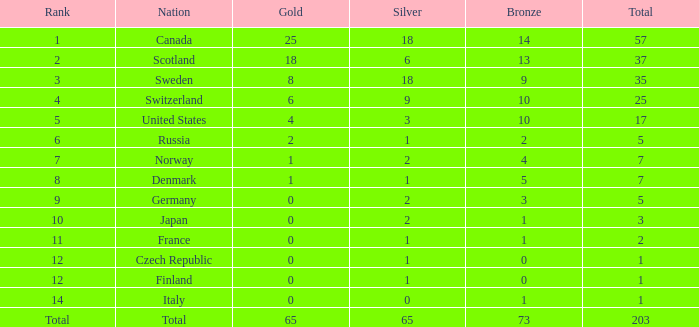What is the lowest total when the rank is 14 and the gold medals is larger than 0? None. Write the full table. {'header': ['Rank', 'Nation', 'Gold', 'Silver', 'Bronze', 'Total'], 'rows': [['1', 'Canada', '25', '18', '14', '57'], ['2', 'Scotland', '18', '6', '13', '37'], ['3', 'Sweden', '8', '18', '9', '35'], ['4', 'Switzerland', '6', '9', '10', '25'], ['5', 'United States', '4', '3', '10', '17'], ['6', 'Russia', '2', '1', '2', '5'], ['7', 'Norway', '1', '2', '4', '7'], ['8', 'Denmark', '1', '1', '5', '7'], ['9', 'Germany', '0', '2', '3', '5'], ['10', 'Japan', '0', '2', '1', '3'], ['11', 'France', '0', '1', '1', '2'], ['12', 'Czech Republic', '0', '1', '0', '1'], ['12', 'Finland', '0', '1', '0', '1'], ['14', 'Italy', '0', '0', '1', '1'], ['Total', 'Total', '65', '65', '73', '203']]} 